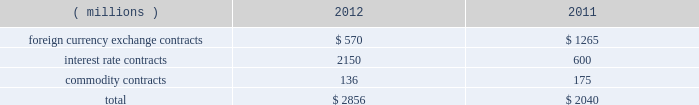Note 12 derivative instruments and fair value measurements the company is exposed to certain market risks such as changes in interest rates , foreign currency exchange rates , and commodity prices , which exist as a part of its ongoing business operations .
Management uses derivative financial and commodity instruments , including futures , options , and swaps , where appropriate , to manage these risks .
Instruments used as hedges must be effective at reducing the risk associated with the exposure being hedged and must be designated as a hedge at the inception of the contract .
The company designates derivatives as cash flow hedges , fair value hedges , net investment hedges , and uses other contracts to reduce volatility in interest rates , foreign currency and commodities .
As a matter of policy , the company does not engage in trading or speculative hedging transactions .
Total notional amounts of the company 2019s derivative instruments as of december 29 , 2012 and december 31 , 2011 were as follows: .
Following is a description of each category in the fair value hierarchy and the financial assets and liabilities of the company that were included in each category at december 29 , 2012 and december 31 , 2011 , measured on a recurring basis .
Level 1 2014 financial assets and liabilities whose values are based on unadjusted quoted prices for identical assets or liabilities in an active market .
For the company , level 1 financial assets and liabilities consist primarily of commodity derivative contracts .
Level 2 2014 financial assets and liabilities whose values are based on quoted prices in markets that are not active or model inputs that are observable either directly or indirectly for substantially the full term of the asset or liability .
For the company , level 2 financial assets and liabilities consist of interest rate swaps and over-the-counter commodity and currency contracts .
The company 2019s calculation of the fair value of interest rate swaps is derived from a discounted cash flow analysis based on the terms of the contract and the interest rate curve .
Over-the-counter commodity derivatives are valued using an income approach based on the commodity index prices less the contract rate multiplied by the notional amount .
Foreign currency contracts are valued using an income approach based on forward rates less the contract rate multiplied by the notional amount .
The company 2019s calculation of the fair value of level 2 financial assets and liabilities takes into consideration the risk of nonperformance , including counterparty credit risk .
Level 3 2014 financial assets and liabilities whose values are based on prices or valuation techniques that require inputs that are both unobservable and significant to the overall fair value measurement .
These inputs reflect management 2019s own assumptions about the assumptions a market participant would use in pricing the asset or liability .
The company did not have any level 3 financial assets or liabilities as of december 29 , 2012 or december 31 , 2011 .
The following table presents assets and liabilities that were measured at fair value in the consolidated balance sheet on a recurring basis as of december 29 , 2012 and december 31 , 2011 : derivatives designated as hedging instruments : 2012 2011 ( millions ) level 1 level 2 total level 1 level 2 total assets : foreign currency exchange contracts : other current assets $ 2014 $ 4 $ 4 $ 2014 $ 11 $ 11 interest rate contracts ( a ) : other assets 2014 64 64 2014 23 23 commodity contracts : other current assets 2014 2014 2014 2 2014 2 total assets $ 2014 $ 68 $ 68 $ 2 $ 34 $ 36 liabilities : foreign currency exchange contracts : other current liabilities $ 2014 $ ( 3 ) $ ( 3 ) $ 2014 $ ( 18 ) $ ( 18 ) commodity contracts : other current liabilities 2014 ( 11 ) ( 11 ) ( 4 ) ( 12 ) ( 16 ) other liabilities 2014 ( 27 ) ( 27 ) 2014 ( 34 ) ( 34 ) total liabilities $ 2014 $ ( 41 ) $ ( 41 ) $ ( 4 ) $ ( 64 ) $ ( 68 ) ( a ) the fair value of the related hedged portion of the company 2019s long-term debt , a level 2 liability , was $ 2.3 billion as of december 29 , 2012 and $ 626 million as of december 31 , derivatives not designated as hedging instruments : 2012 2011 ( millions ) level 1 level 2 total level 1 level 2 total assets : commodity contracts : other current assets $ 5 $ 2014 $ 5 $ 2014 $ 2014 $ 2014 total assets $ 5 $ 2014 $ 5 $ 2014 $ 2014 $ 2014 liabilities : commodity contracts : other current liabilities $ ( 3 ) $ 2014 $ ( 3 ) $ 2014 $ 2014 $ 2014 total liabilities $ ( 3 ) $ 2014 $ ( 3 ) $ 2014 $ 2014 $ 2014 .
In 2012 what was the percent of the notional amounts of the company 2019s derivative instruments for interest rate contracts? 
Computations: (2150 / 2856)
Answer: 0.7528. 